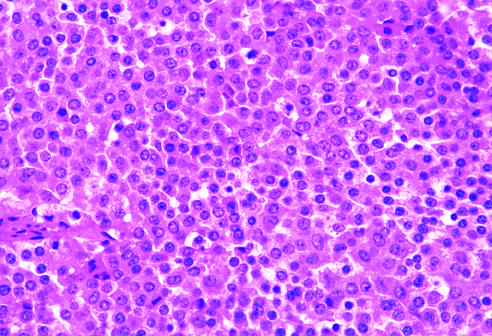does the monomorphism of these cells contrast with the admixture of cells seen in the normal anterior pituitary gland?
Answer the question using a single word or phrase. Yes 